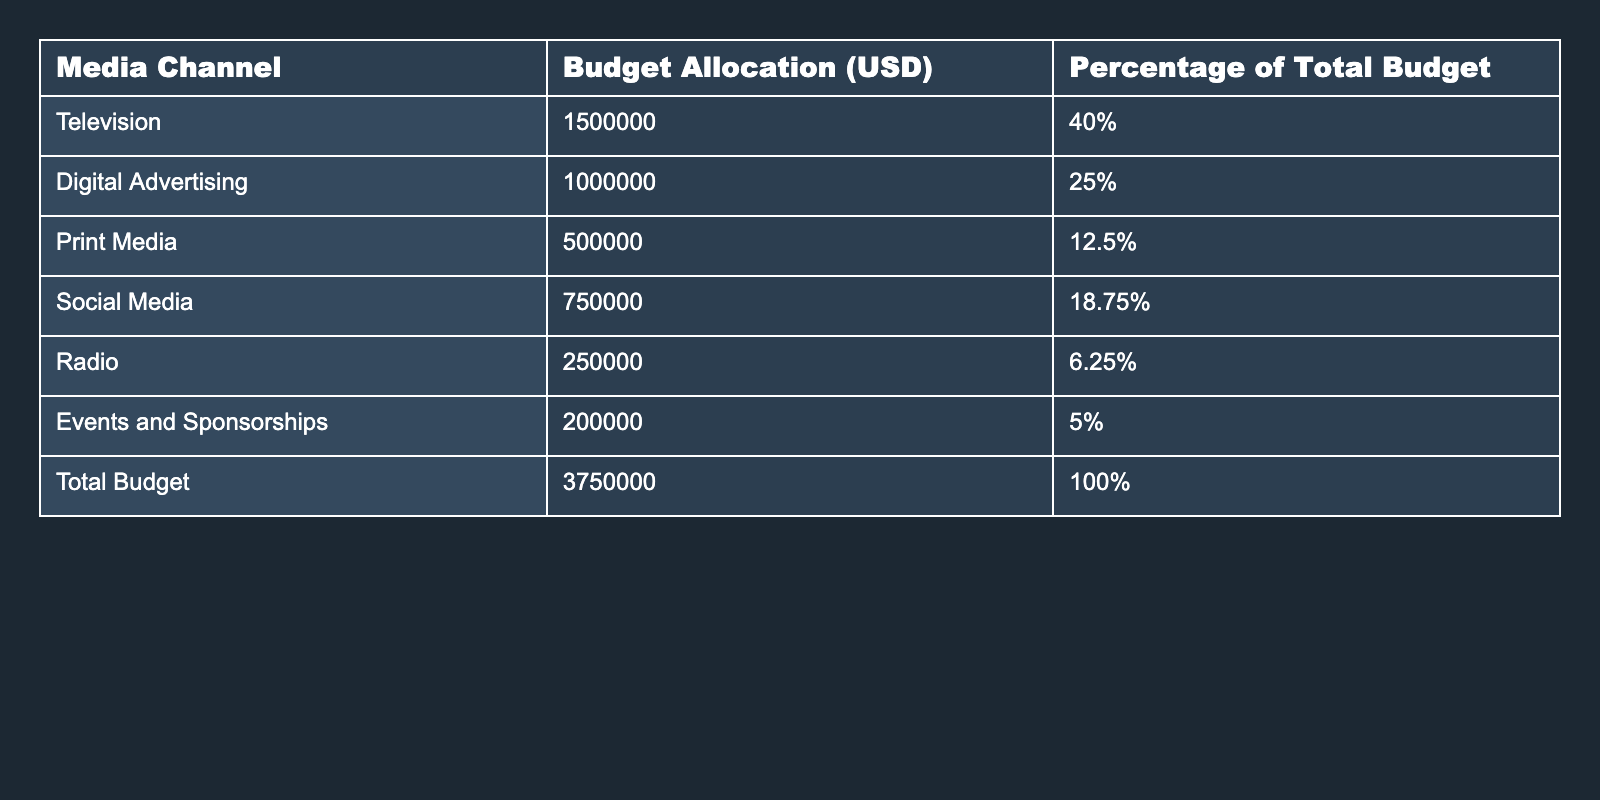What is the budget allocation for Digital Advertising? The table lists the budget allocation for Digital Advertising directly, showing it is $1,000,000.
Answer: $1,000,000 What percentage of the total budget is allocated to Social Media? The table indicates that Social Media is allocated 18.75% of the total budget.
Answer: 18.75% Which media channel has the highest budget allocation? The table shows that Television has the highest budget allocation, amounting to $1,500,000.
Answer: Television What is the total budget for all media channels? The total budget, as stated in the table, is $3,750,000.
Answer: $3,750,000 What is the difference in budget allocation between Television and Print Media? The budget allocation for Television is $1,500,000, and for Print Media, it is $500,000. The difference is $1,500,000 - $500,000 = $1,000,000.
Answer: $1,000,000 What is the combined budget allocation for Radio and Events and Sponsorships? Radio has a budget of $250,000 and Events and Sponsorships have $200,000. Their combined budget is $250,000 + $200,000 = $450,000.
Answer: $450,000 Is the budget allocation for Social Media more than the budget allocation for Print Media? Social Media has $750,000 while Print Media has $500,000. Since $750,000 is greater than $500,000, the statement is true.
Answer: Yes What is the percentage of the budget allocated to Traditional Media channels (Television, Print Media, and Radio)? The percentages for Traditional Media are 40% (Television), 12.5% (Print Media), and 6.25% (Radio). Their total is 40% + 12.5% + 6.25% = 58.75%.
Answer: 58.75% If the budget for Digital Advertising were to increase by 10%, what would the new budget allocation be? The current budget for Digital Advertising is $1,000,000. A 10% increase would be $1,000,000 * 0.10 = $100,000, leading to a new budget of $1,000,000 + $100,000 = $1,100,000.
Answer: $1,100,000 Which media channel accounts for less than 10% of the total budget? According to the table, only Radio (6.25%) and Events and Sponsorships (5%) have allocations less than 10%.
Answer: Radio and Events and Sponsorships 